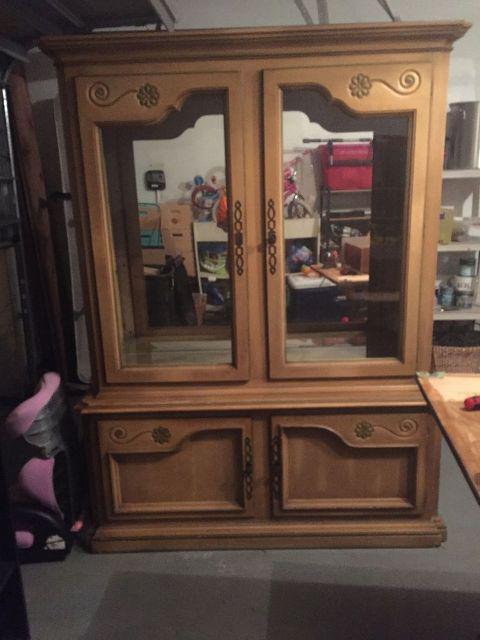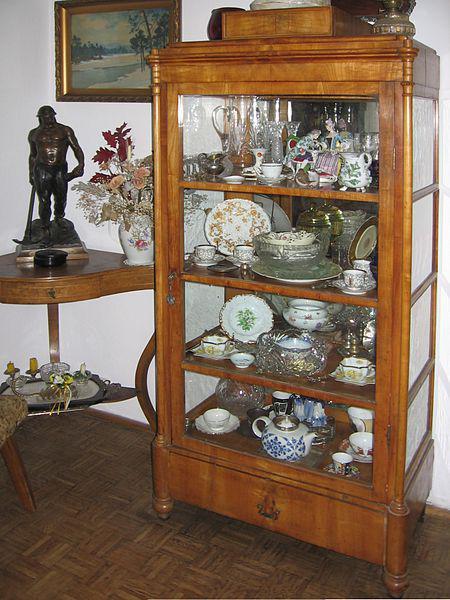The first image is the image on the left, the second image is the image on the right. For the images displayed, is the sentence "One china cabinet has three stacked drawers on the bottom and three upper shelves filled with dishes." factually correct? Answer yes or no. No. 